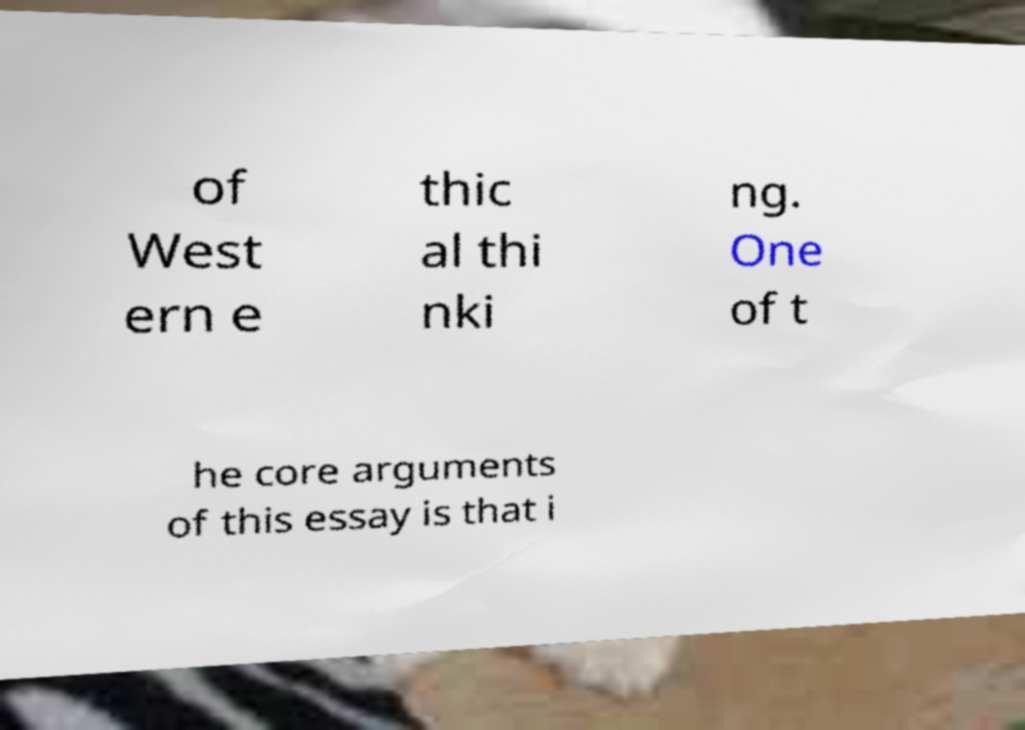For documentation purposes, I need the text within this image transcribed. Could you provide that? of West ern e thic al thi nki ng. One of t he core arguments of this essay is that i 